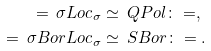Convert formula to latex. <formula><loc_0><loc_0><loc_500><loc_500>= \, { \sigma L o c } _ { \sigma } & \simeq \, { Q P o l } \colon = , \\ = \, { \sigma B o r L o c } _ { \sigma } & \simeq \, { S B o r } \colon = .</formula> 